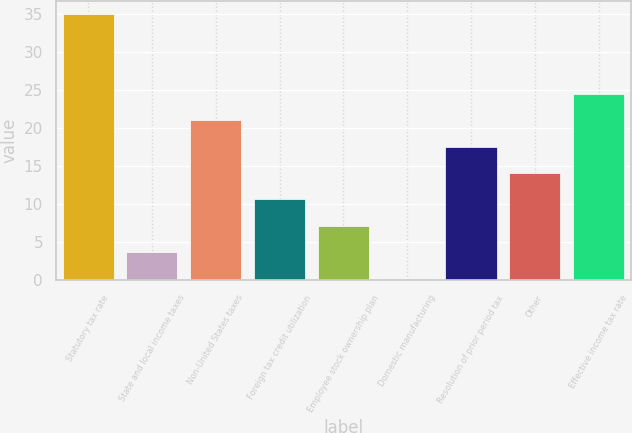Convert chart. <chart><loc_0><loc_0><loc_500><loc_500><bar_chart><fcel>Statutory tax rate<fcel>State and local income taxes<fcel>Non-United States taxes<fcel>Foreign tax credit utilization<fcel>Employee stock ownership plan<fcel>Domestic manufacturing<fcel>Resolution of prior period tax<fcel>Other<fcel>Effective income tax rate<nl><fcel>35<fcel>3.68<fcel>21.08<fcel>10.64<fcel>7.16<fcel>0.2<fcel>17.6<fcel>14.12<fcel>24.56<nl></chart> 